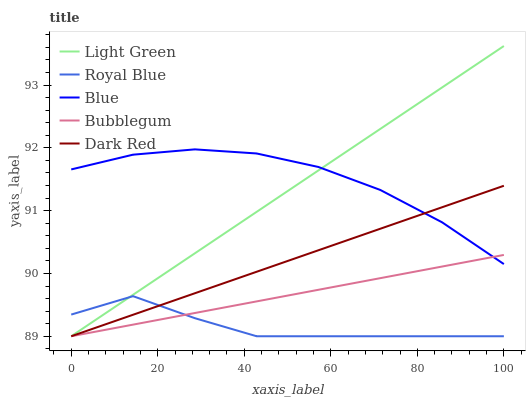Does Royal Blue have the minimum area under the curve?
Answer yes or no. Yes. Does Blue have the maximum area under the curve?
Answer yes or no. Yes. Does Bubblegum have the minimum area under the curve?
Answer yes or no. No. Does Bubblegum have the maximum area under the curve?
Answer yes or no. No. Is Bubblegum the smoothest?
Answer yes or no. Yes. Is Royal Blue the roughest?
Answer yes or no. Yes. Is Royal Blue the smoothest?
Answer yes or no. No. Is Bubblegum the roughest?
Answer yes or no. No. Does Royal Blue have the lowest value?
Answer yes or no. Yes. Does Light Green have the highest value?
Answer yes or no. Yes. Does Bubblegum have the highest value?
Answer yes or no. No. Is Royal Blue less than Blue?
Answer yes or no. Yes. Is Blue greater than Royal Blue?
Answer yes or no. Yes. Does Bubblegum intersect Dark Red?
Answer yes or no. Yes. Is Bubblegum less than Dark Red?
Answer yes or no. No. Is Bubblegum greater than Dark Red?
Answer yes or no. No. Does Royal Blue intersect Blue?
Answer yes or no. No. 